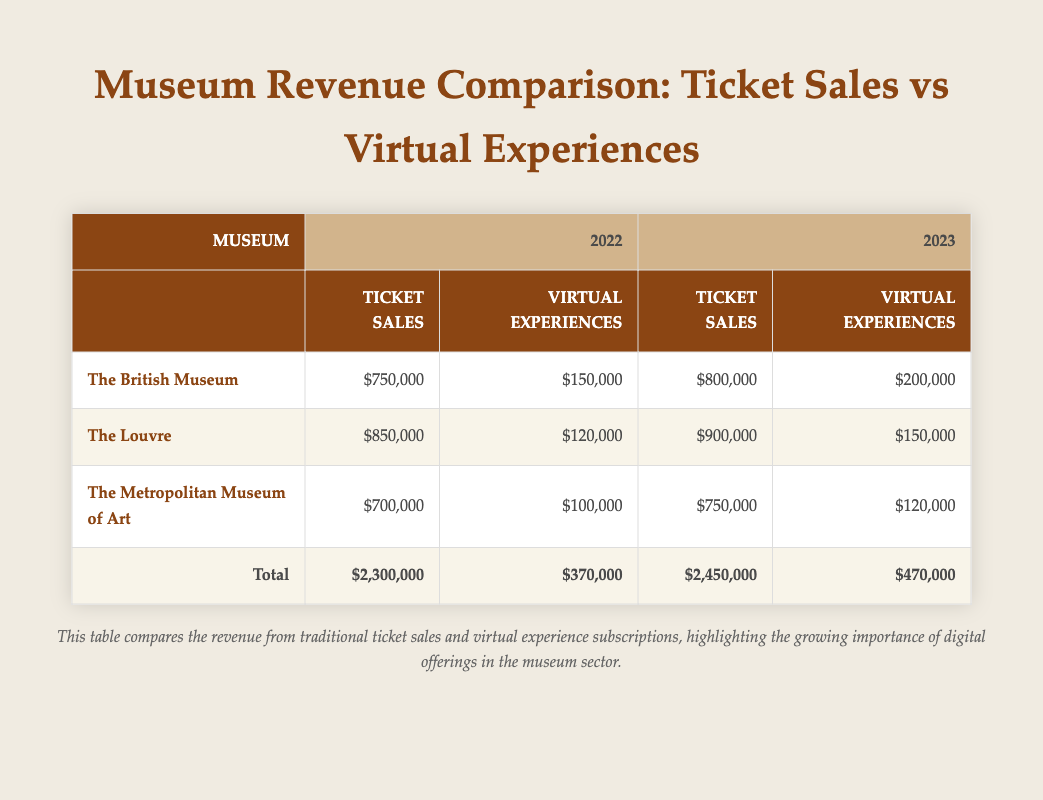What was the ticket sales revenue for The Louvre in 2022? The table shows that The Louvre's ticket sales revenue for 2022 is listed as $850,000 in the respective column.
Answer: $850,000 What was the total revenue generated from virtual experience subscriptions across all museums in 2023? To find the total for 2023, we add the virtual experience subscriptions for each museum: $200,000 (British Museum) + $150,000 (Louvre) + $120,000 (Metropolitan Museum) = $470,000.
Answer: $470,000 Did ticket sales increase for The British Museum from 2022 to 2023? The table indicates that The British Museum's ticket sales were $750,000 in 2022 and increased to $800,000 in 2023, which confirms an increase.
Answer: Yes Which museum had the highest virtual experience subscriptions in 2022? The table lists The British Museum with $150,000, The Louvre with $120,000, and The Metropolitan Museum with $100,000 for 2022. The British Museum has the highest value among these.
Answer: The British Museum What was the difference in ticket sales between The Metropolitan Museum of Art for 2022 and 2023? For The Metropolitan Museum of Art, ticket sales are $700,000 in 2022 and $750,000 in 2023. The difference is $750,000 - $700,000 = $50,000.
Answer: $50,000 Was the total revenue from ticket sales in 2022 greater than that from virtual experience subscriptions? The total ticket sales revenue in 2022 is $2,300,000, and the total from virtual experience subscriptions is $370,000, showing that ticket sales are significantly greater.
Answer: Yes Which museum saw the largest increase in virtual experience subscriptions from 2022 to 2023? The virtual experience subscriptions increased from $150,000 to $200,000 for The British Museum, an increase of $50,000. For The Louvre, the increase was $30,000 (from $120,000 to $150,000), and for The Metropolitan Museum, it was $20,000 (from $100,000 to $120,000). The British Museum had the largest increase.
Answer: The British Museum What is the average ticket sales revenue for all three museums in 2022? To calculate the average, add the ticket sales: $750,000 (British Museum) + $850,000 (Louvre) + $700,000 (Metropolitan Museum) = $2,300,000. Then divide by 3: $2,300,000 / 3 = $766,666.67.
Answer: $766,666.67 